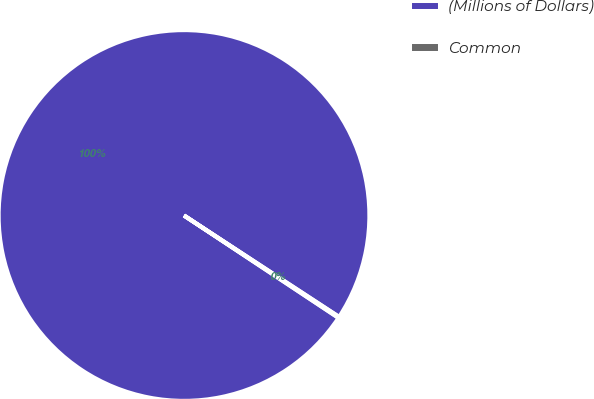Convert chart to OTSL. <chart><loc_0><loc_0><loc_500><loc_500><pie_chart><fcel>(Millions of Dollars)<fcel>Common<nl><fcel>99.9%<fcel>0.1%<nl></chart> 